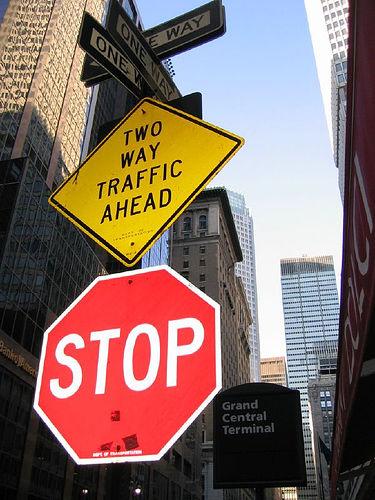Is there a peace sign here?
Quick response, please. No. Is this a parking area?
Quick response, please. No. What does it say above "Ahead"?
Answer briefly. Traffic. What street is on the yellow sign?
Answer briefly. Two way. What does the sign mean?
Be succinct. Stop. Why is the bottom sign funny?
Short answer required. It's not. Is this commercial or residential pic?
Answer briefly. Commercial. What is the writing on the top?
Be succinct. One way. What does the sign say?
Answer briefly. Stop. How many ways?
Answer briefly. 2. How many different signs are there?
Keep it brief. 6. Why are there shadows?
Answer briefly. Sun. 